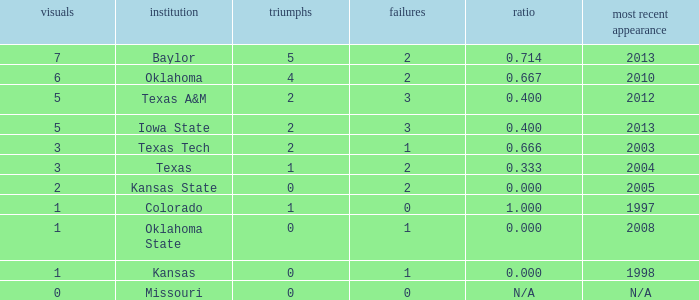What's the largest amount of wins Texas has?  1.0. 